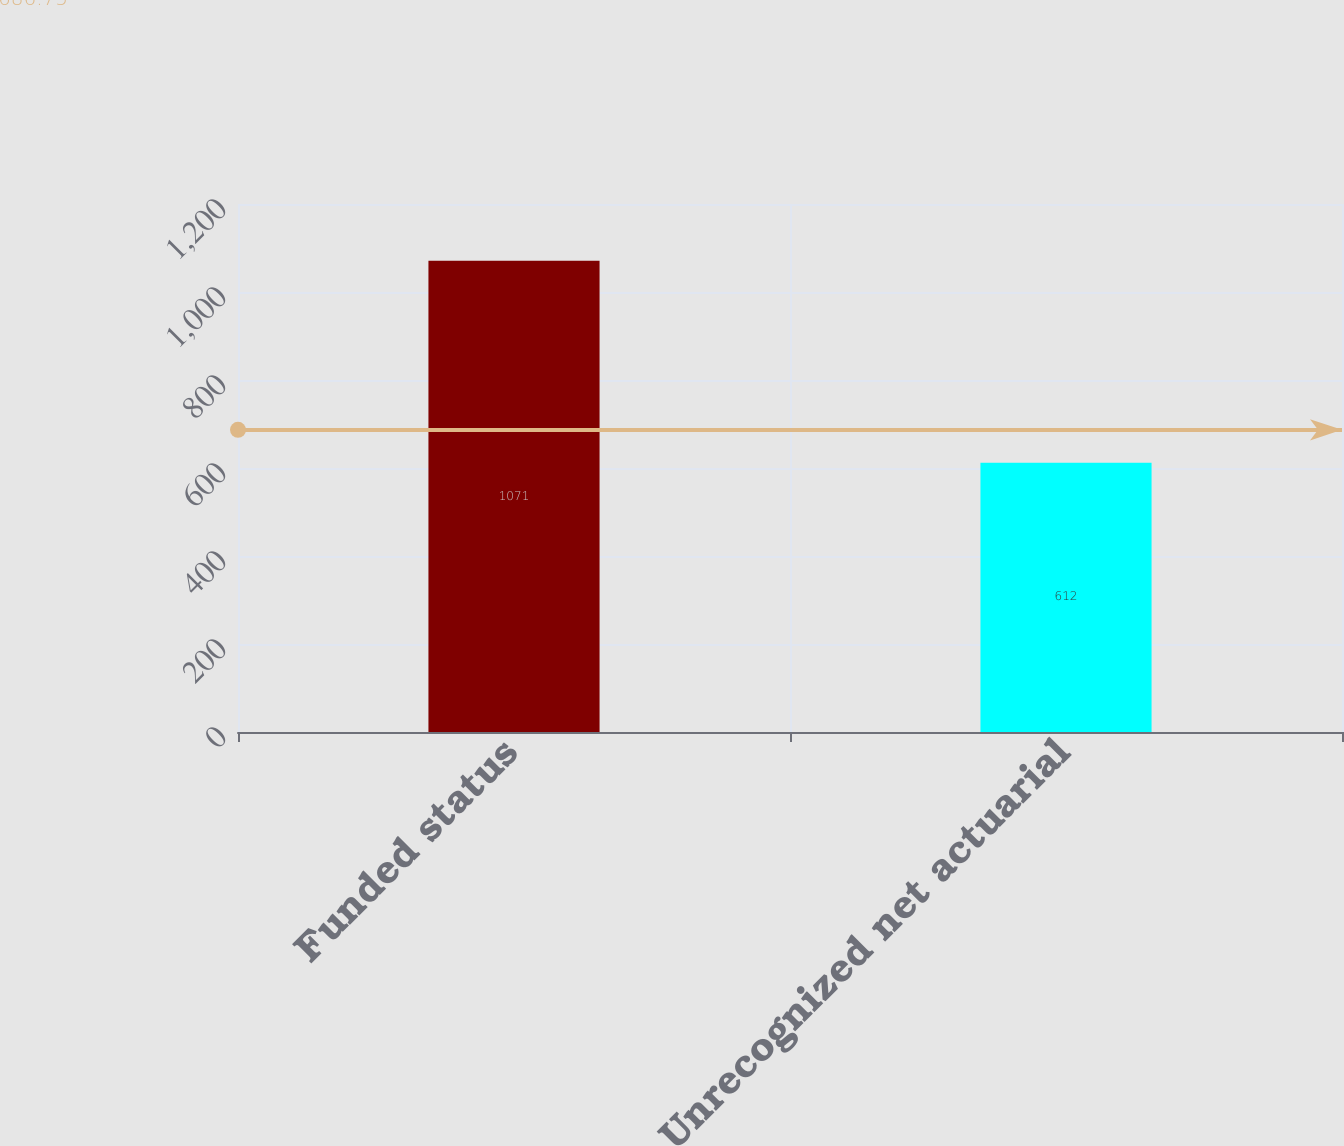<chart> <loc_0><loc_0><loc_500><loc_500><bar_chart><fcel>Funded status<fcel>Unrecognized net actuarial<nl><fcel>1071<fcel>612<nl></chart> 